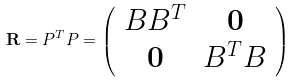<formula> <loc_0><loc_0><loc_500><loc_500>\mathbf R = P ^ { T } P = \left ( \begin{array} { c c } B B ^ { T } & \mathbf 0 \\ \mathbf 0 & B ^ { T } B \\ \end{array} \right )</formula> 